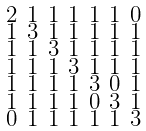Convert formula to latex. <formula><loc_0><loc_0><loc_500><loc_500>\begin{smallmatrix} 2 & 1 & 1 & 1 & 1 & 1 & 0 \\ 1 & 3 & 1 & 1 & 1 & 1 & 1 \\ 1 & 1 & 3 & 1 & 1 & 1 & 1 \\ 1 & 1 & 1 & 3 & 1 & 1 & 1 \\ 1 & 1 & 1 & 1 & 3 & 0 & 1 \\ 1 & 1 & 1 & 1 & 0 & 3 & 1 \\ 0 & 1 & 1 & 1 & 1 & 1 & 3 \end{smallmatrix}</formula> 